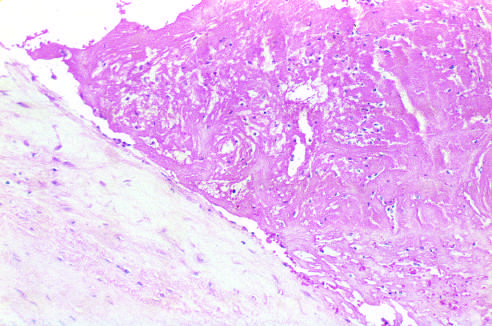s gram only loosely attached to the cusp?
Answer the question using a single word or phrase. No 